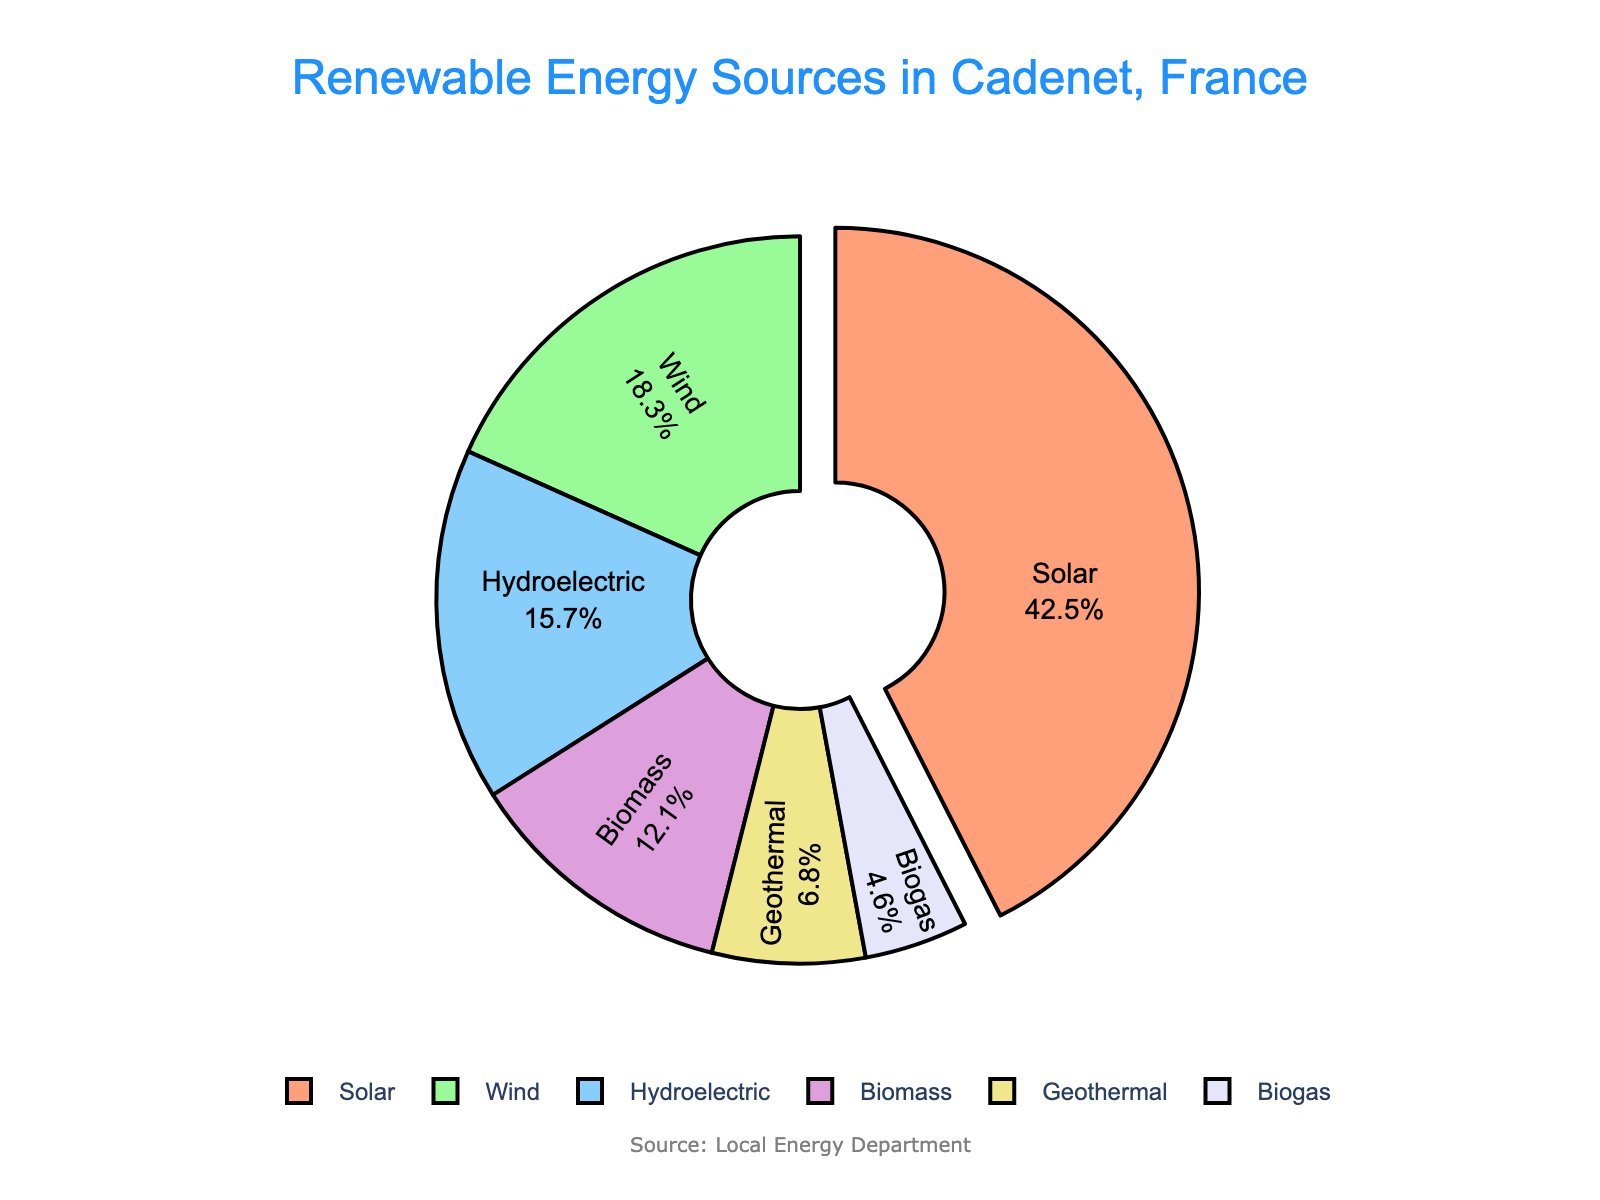What percentage of renewable energy comes from sources other than solar and wind? First, note the contributions from Solar (42.5%) and Wind (18.3%). Add these two percentages: 42.5% + 18.3% = 60.8%. Subtract this sum from 100% to find the percentage from other sources: 100% - 60.8% = 39.2%.
Answer: 39.2% How much greater is the percentage of solar energy compared to hydroelectric energy? Identify the percentages for Solar (42.5%) and Hydroelectric (15.7%). Subtract the hydroelectric percentage from solar: 42.5% - 15.7% = 26.8%.
Answer: 26.8% Which energy source contributes the least to Cadenet's renewable energy mix? Compare the percentages of all energy sources: Solar (42.5%), Wind (18.3%), Hydroelectric (15.7%), Biomass (12.1%), Geothermal (6.8%), and Biogas (4.6%). The lowest percentage is Biogas at 4.6%.
Answer: Biogas What is the combined percentage of geothermal and biogas energy sources? Identify the percentages for Geothermal (6.8%) and Biogas (4.6%). Add these two percentages: 6.8% + 4.6% = 11.4%.
Answer: 11.4% Does biomass contribute more to the renewable energy mix than hydroelectric? Compare the percentages for Biogas (12.1%) and Hydroelectric (15.7%). Biomass (12.1%) is less than Hydroelectric (15.7%).
Answer: No Which two sources combined make up nearly 60% of the renewable energy mix? Define the highest percentages and combine them sequentially: Solar (42.5%) + Wind (18.3%) = 60.8%. Considering these steps, Solar and Wind combined closely make up 60% of the renewable energy mix.
Answer: Solar and Wind Which color is associated with Wind energy in the chart? Identify the color assigned to Wind energy, which in the chart is green.
Answer: Green 